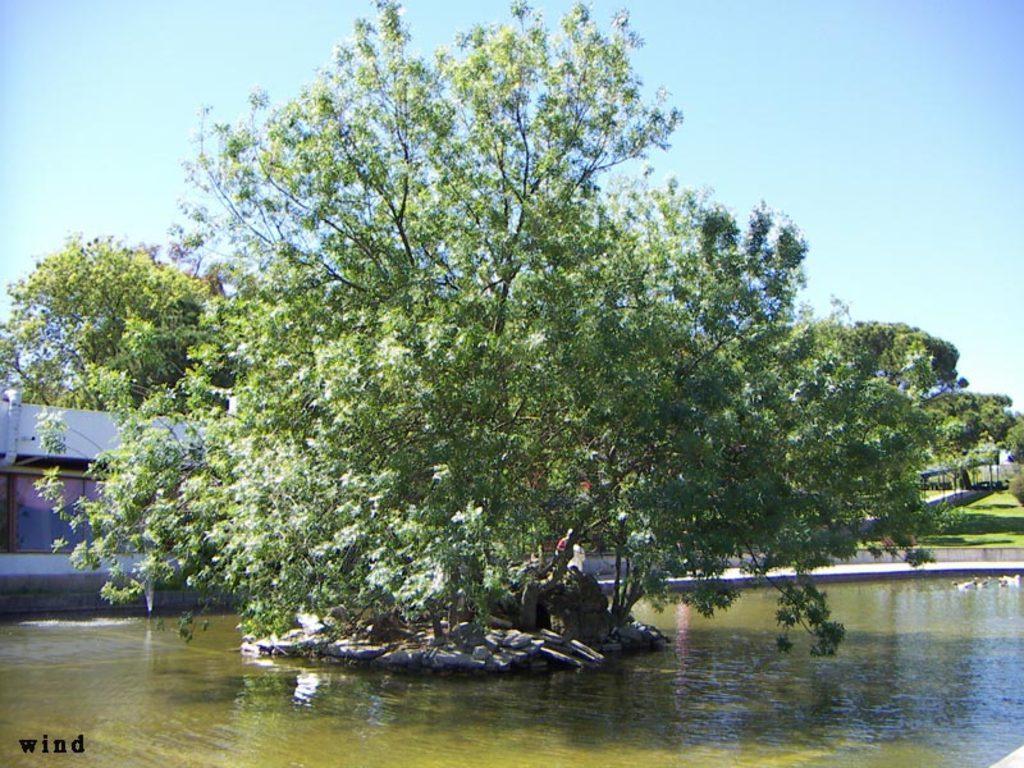Describe this image in one or two sentences. In this image there is the water. In the center of the water there is a tree. There are stones around the tree. In the background there is a house. To the right there's grass on the ground. At the top there is the sky. 